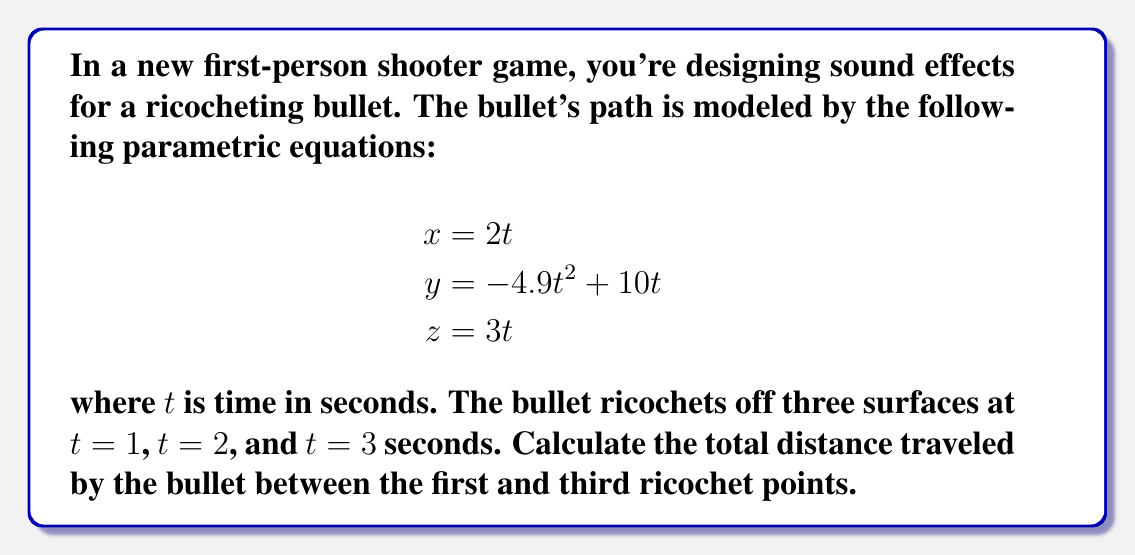Teach me how to tackle this problem. To solve this problem, we need to follow these steps:

1) First, we need to find the coordinates of the ricochet points at $t = 1$ and $t = 3$.

2) Then, we'll calculate the distance between these two points using the distance formula in 3D space.

Step 1: Finding the coordinates

For $t = 1$ (first ricochet):
$$\begin{aligned}
x_1 &= 2(1) = 2 \\
y_1 &= -4.9(1)^2 + 10(1) = 5.1 \\
z_1 &= 3(1) = 3
\end{aligned}$$

So, the first ricochet point is $(2, 5.1, 3)$.

For $t = 3$ (third ricochet):
$$\begin{aligned}
x_3 &= 2(3) = 6 \\
y_3 &= -4.9(3)^2 + 10(3) = -14.1 \\
z_3 &= 3(3) = 9
\end{aligned}$$

So, the third ricochet point is $(6, -14.1, 9)$.

Step 2: Calculating the distance

We can use the 3D distance formula:

$$d = \sqrt{(x_2-x_1)^2 + (y_2-y_1)^2 + (z_2-z_1)^2}$$

Plugging in our values:

$$\begin{aligned}
d &= \sqrt{(6-2)^2 + (-14.1-5.1)^2 + (9-3)^2} \\
&= \sqrt{4^2 + (-19.2)^2 + 6^2} \\
&= \sqrt{16 + 368.64 + 36} \\
&= \sqrt{420.64} \\
&\approx 20.51
\end{aligned}$$

Therefore, the total distance traveled by the bullet between the first and third ricochet points is approximately 20.51 units.
Answer: 20.51 units 